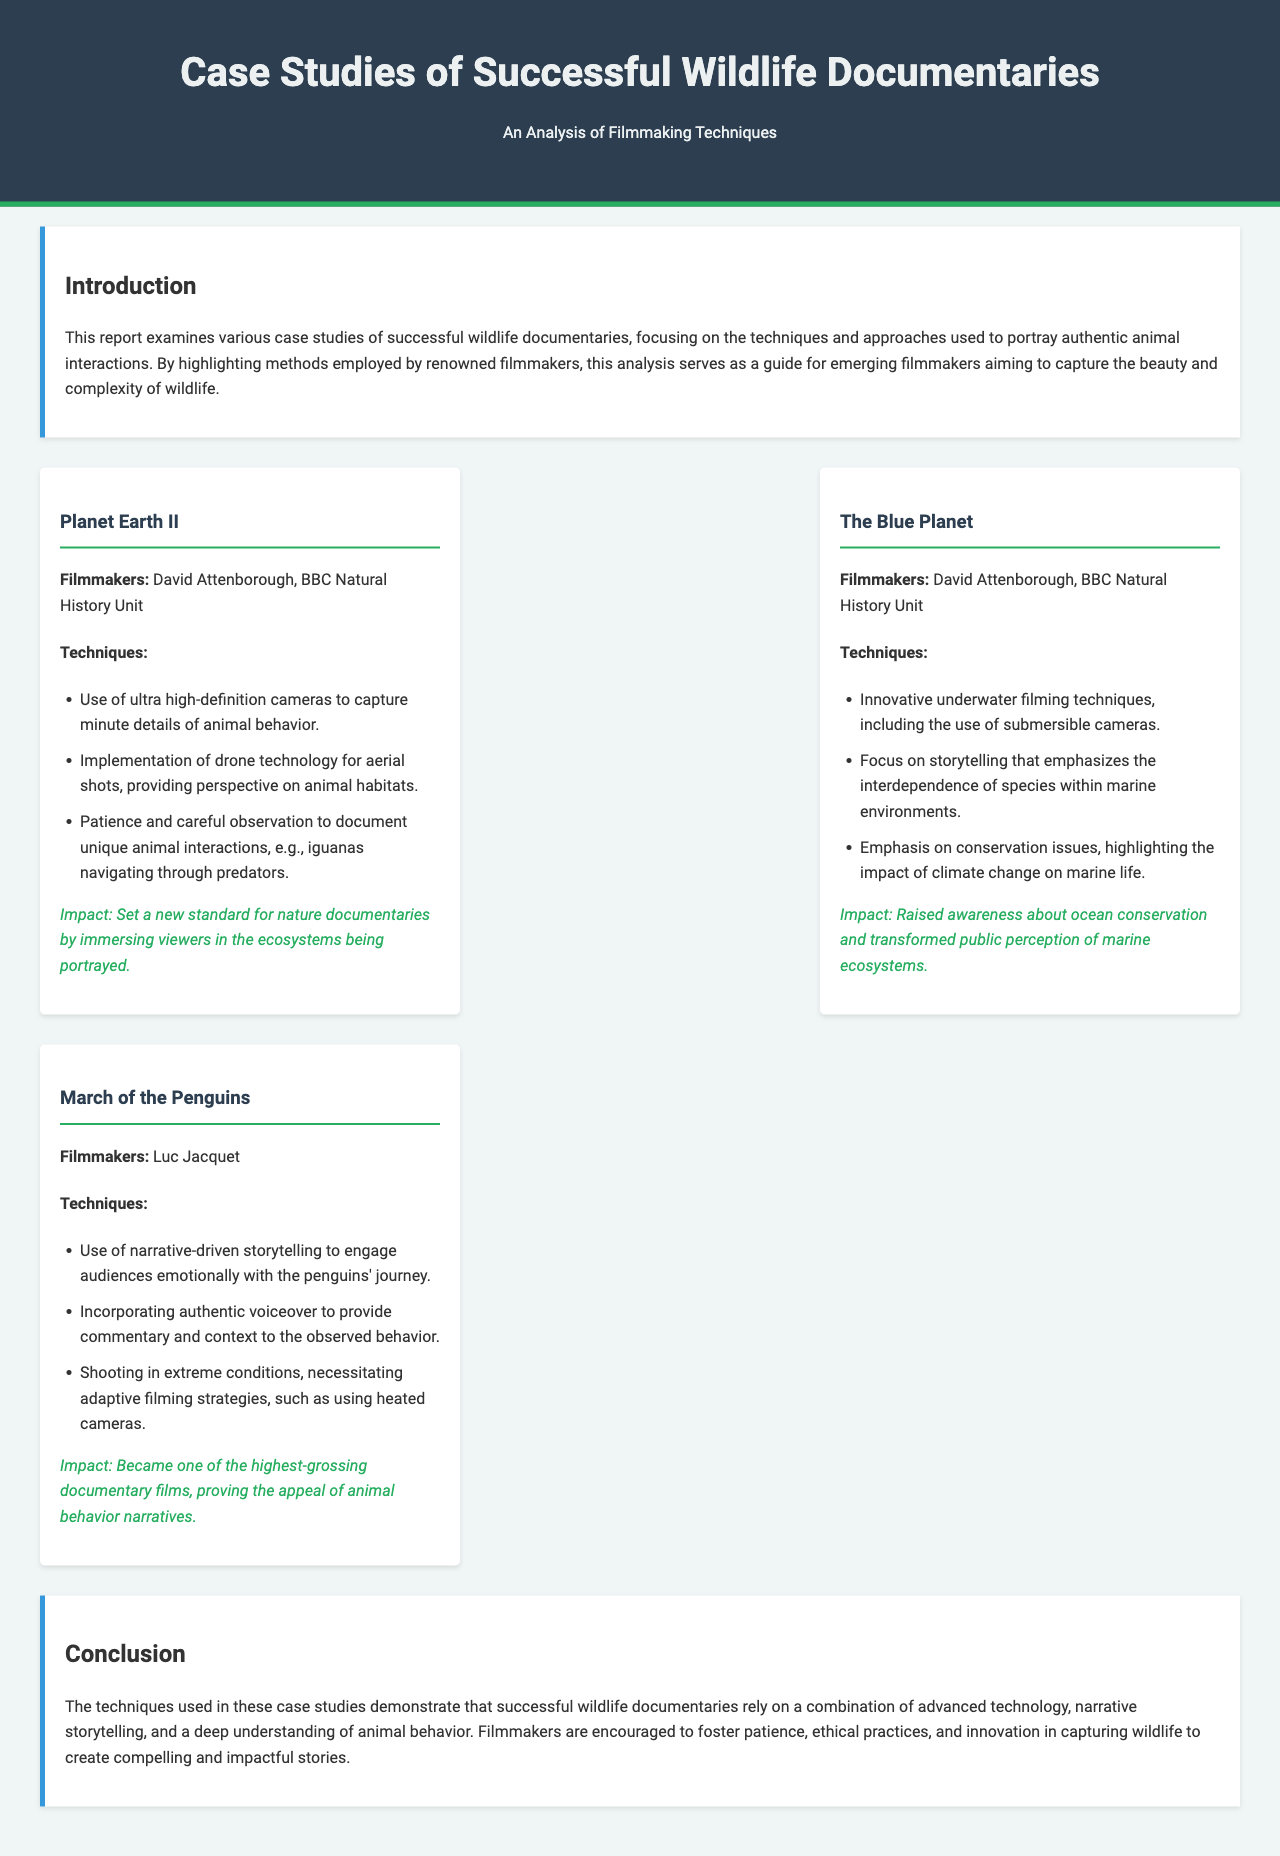What is the title of the report? The title of the report is stated in the document header as "Case Studies of Successful Wildlife Documentaries".
Answer: Case Studies of Successful Wildlife Documentaries Who are the filmmakers of "Planet Earth II"? The filmmakers of "Planet Earth II" are mentioned in the case study section of the document.
Answer: David Attenborough, BBC Natural History Unit What innovative technique was used in "The Blue Planet"? The document lists several techniques, one of which is focused on the innovative methods used in underwater filming.
Answer: Submersible cameras What type of storytelling did "March of the Penguins" utilize? The document notes that "March of the Penguins" engaged audiences through a specific style of storytelling.
Answer: Narrative-driven storytelling What impact did "Planet Earth II" have on wildlife documentaries? The case study section describes the influence of "Planet Earth II" on the industry.
Answer: Set a new standard for nature documentaries Which documentary emphasized conservation issues? The document details which of the case studies highlighted specific themes, including conservation.
Answer: The Blue Planet How many case studies are mentioned in the report? The report provides information on three distinct case studies of wildlife documentaries.
Answer: Three What is highlighted as necessary for adopting filming strategies in extreme conditions? The document mentions adaptive filming strategies in relation to the conditions faced by filmmakers.
Answer: Heated cameras 